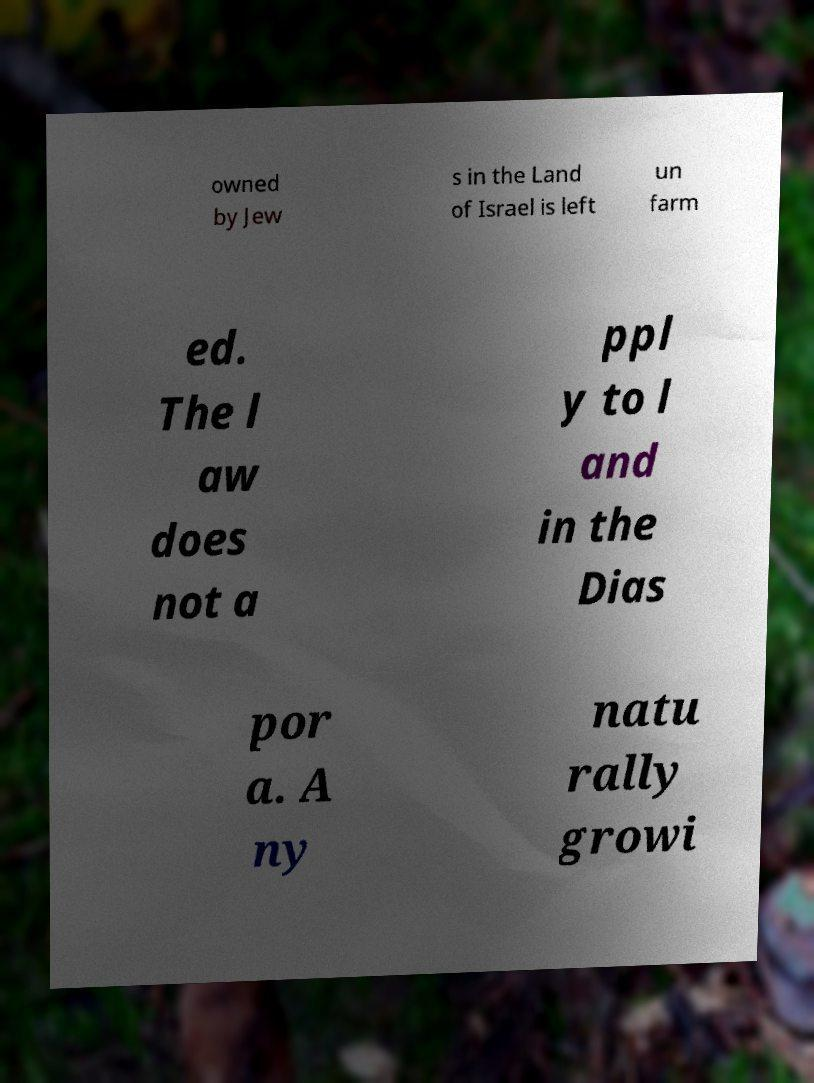What messages or text are displayed in this image? I need them in a readable, typed format. owned by Jew s in the Land of Israel is left un farm ed. The l aw does not a ppl y to l and in the Dias por a. A ny natu rally growi 